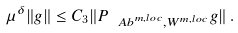<formula> <loc_0><loc_0><loc_500><loc_500>\mu ^ { \delta } \| g \| \leq C _ { 3 } \| P _ { { \ A b } ^ { m , l o c } , W ^ { m , l o c } } g \| \, .</formula> 